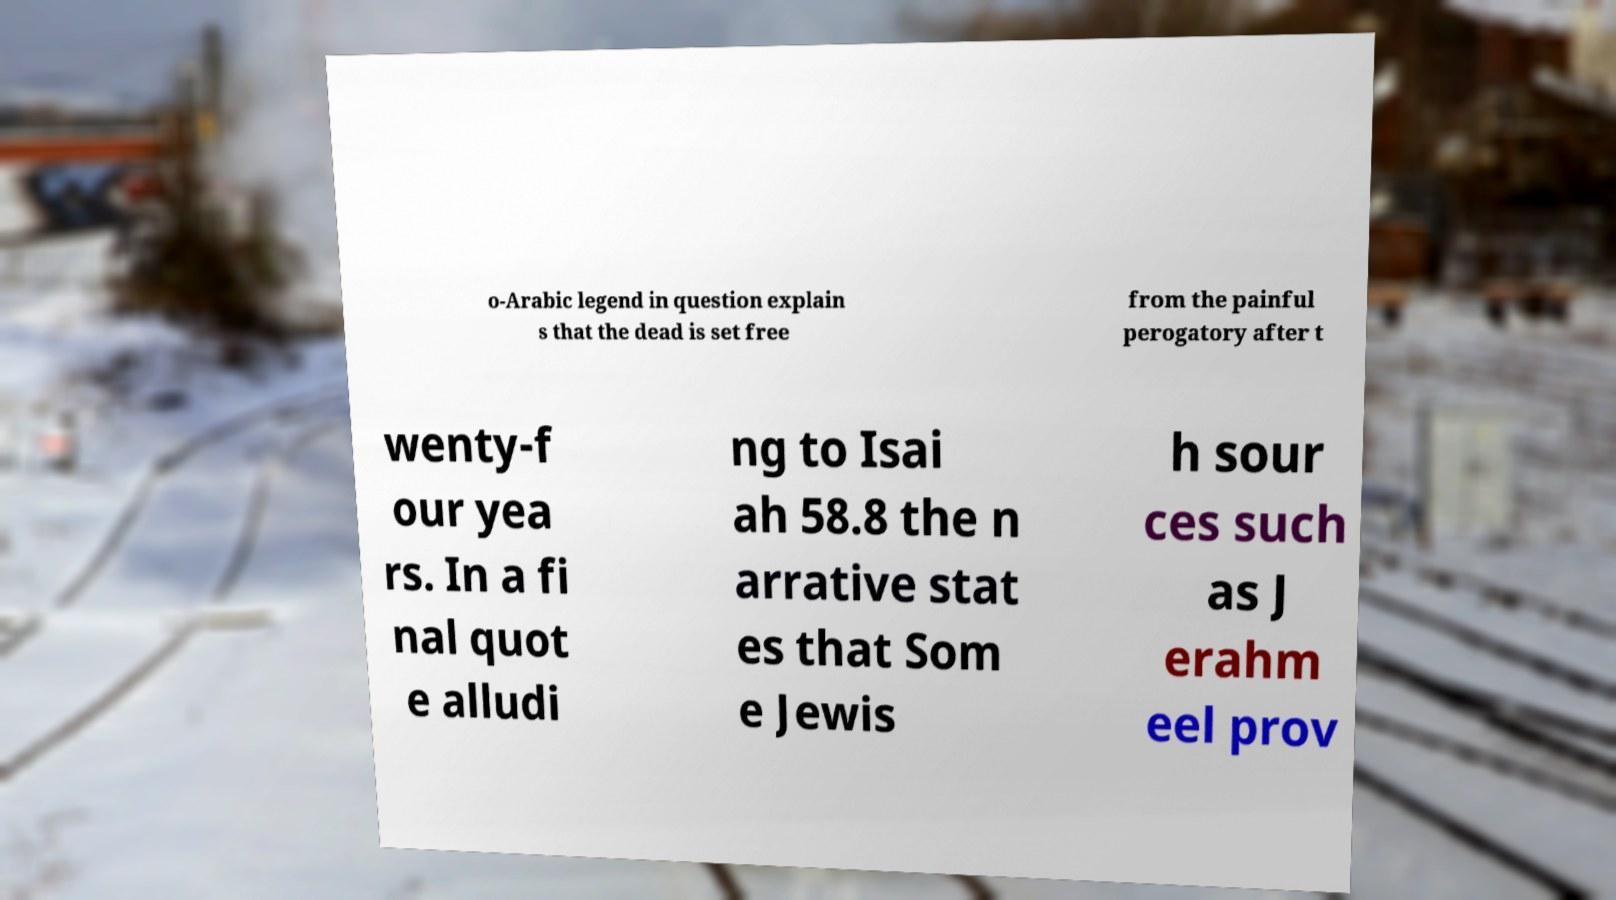Please identify and transcribe the text found in this image. o-Arabic legend in question explain s that the dead is set free from the painful perogatory after t wenty-f our yea rs. In a fi nal quot e alludi ng to Isai ah 58.8 the n arrative stat es that Som e Jewis h sour ces such as J erahm eel prov 